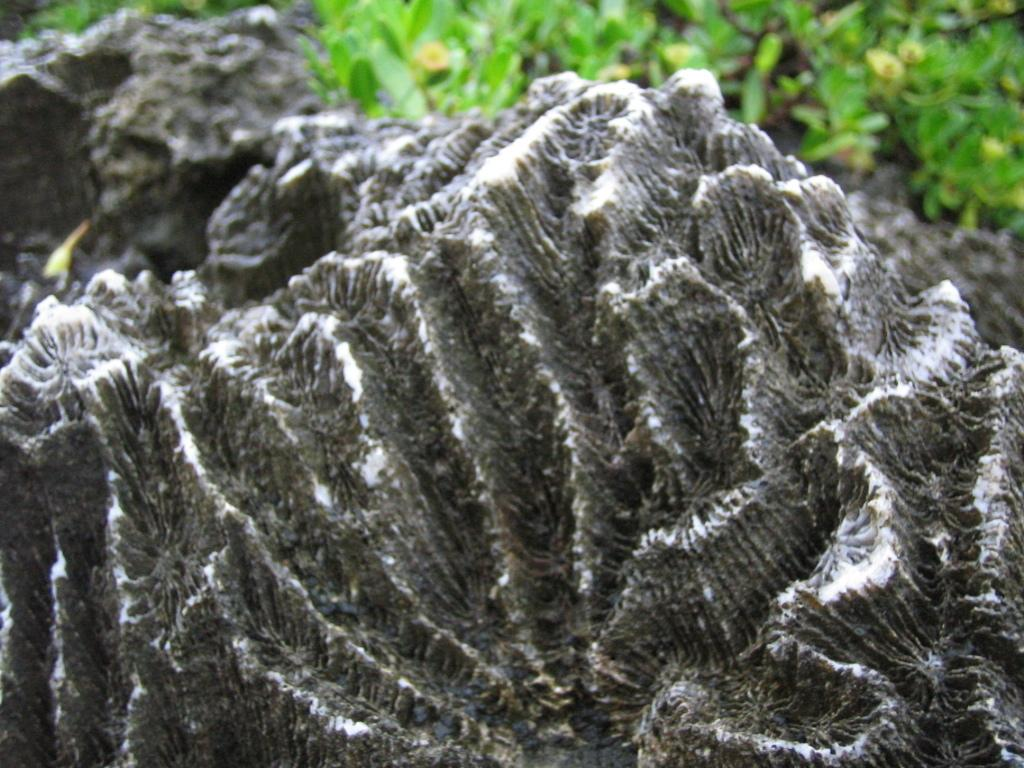What is the main subject of the image? The main subject of the image is a tree trunk. Can you describe the surroundings of the tree trunk? There are plants visible behind the tree trunk. Is there an arch visible in the image? No, there is no arch present in the image. Can you describe the goose that is sitting on the tree trunk? There is no goose present in the image; the main subject is the tree trunk and the surrounding plants. 